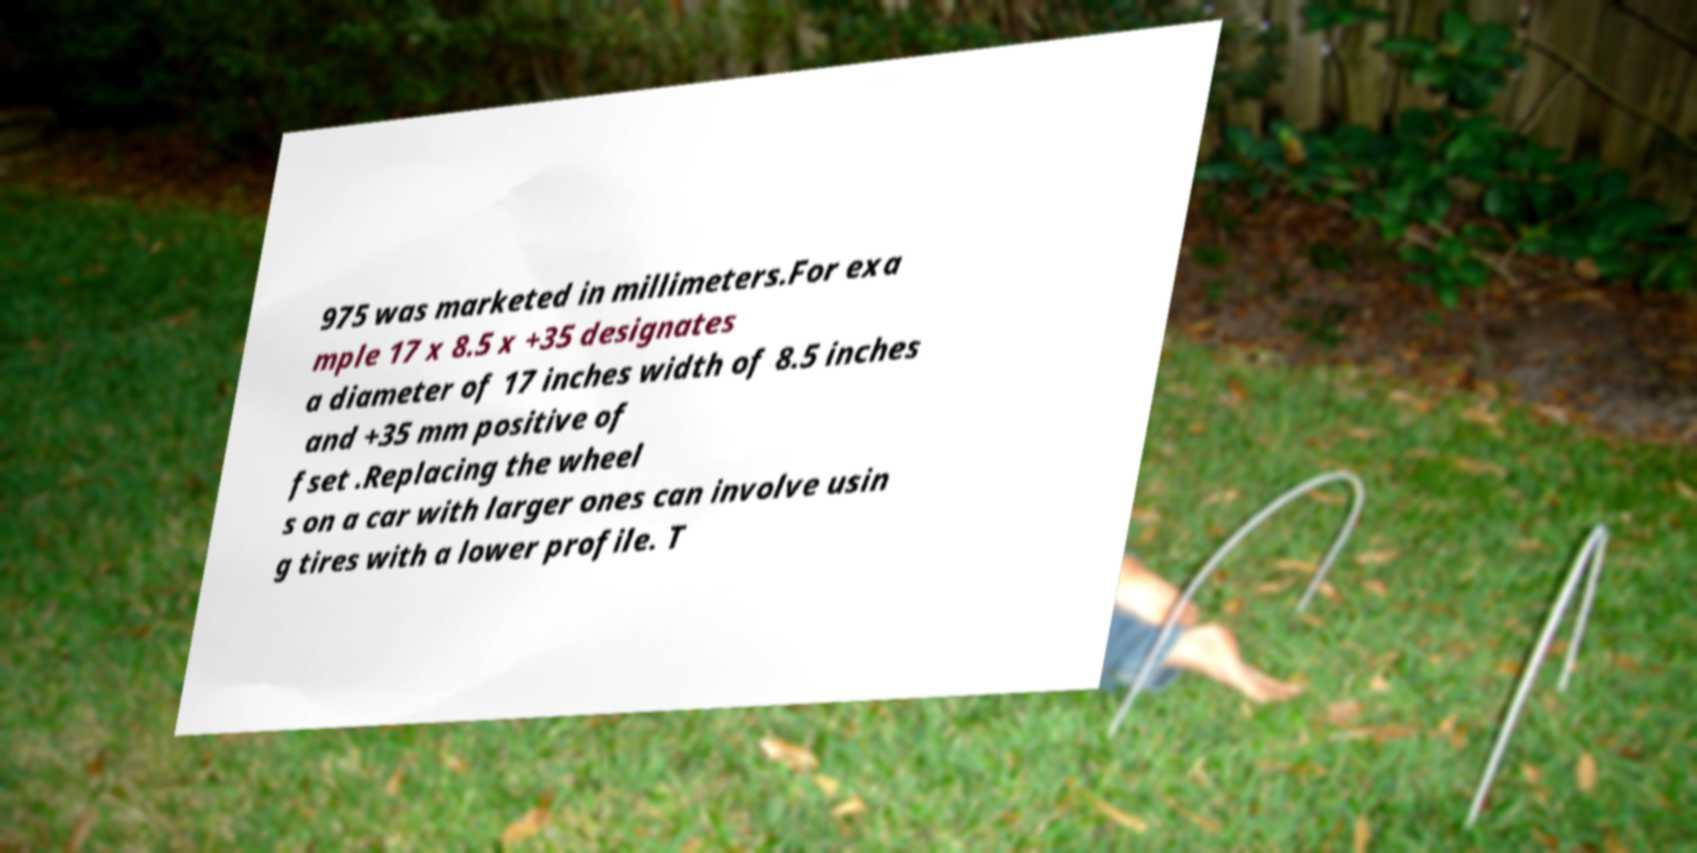Could you assist in decoding the text presented in this image and type it out clearly? 975 was marketed in millimeters.For exa mple 17 x 8.5 x +35 designates a diameter of 17 inches width of 8.5 inches and +35 mm positive of fset .Replacing the wheel s on a car with larger ones can involve usin g tires with a lower profile. T 